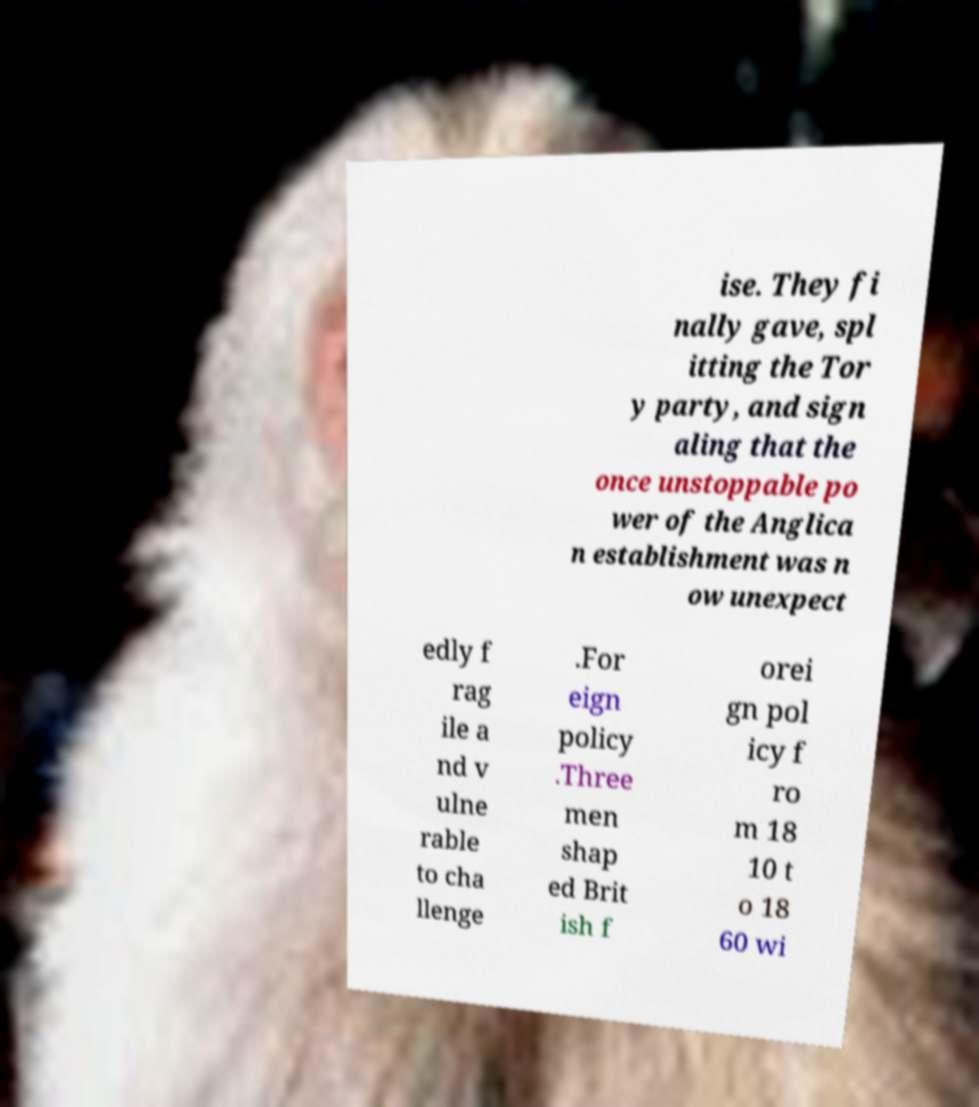Please identify and transcribe the text found in this image. ise. They fi nally gave, spl itting the Tor y party, and sign aling that the once unstoppable po wer of the Anglica n establishment was n ow unexpect edly f rag ile a nd v ulne rable to cha llenge .For eign policy .Three men shap ed Brit ish f orei gn pol icy f ro m 18 10 t o 18 60 wi 